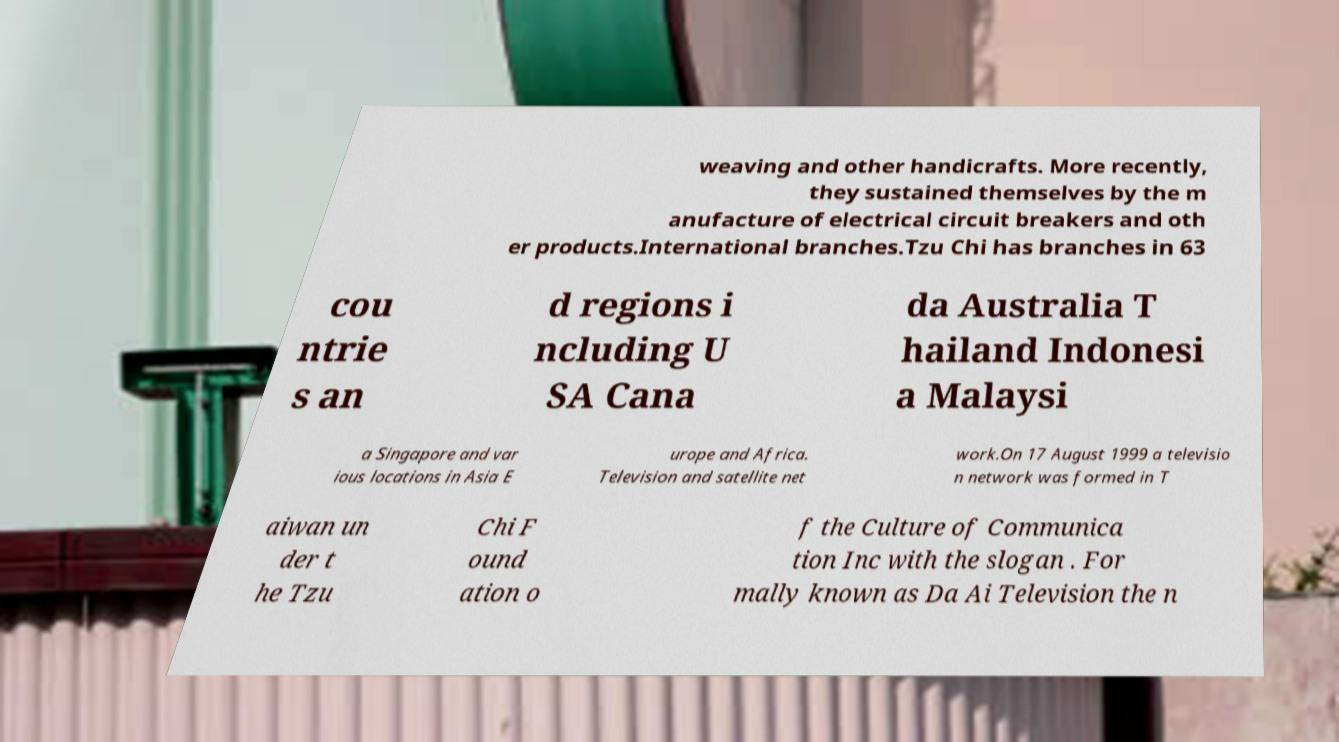I need the written content from this picture converted into text. Can you do that? weaving and other handicrafts. More recently, they sustained themselves by the m anufacture of electrical circuit breakers and oth er products.International branches.Tzu Chi has branches in 63 cou ntrie s an d regions i ncluding U SA Cana da Australia T hailand Indonesi a Malaysi a Singapore and var ious locations in Asia E urope and Africa. Television and satellite net work.On 17 August 1999 a televisio n network was formed in T aiwan un der t he Tzu Chi F ound ation o f the Culture of Communica tion Inc with the slogan . For mally known as Da Ai Television the n 